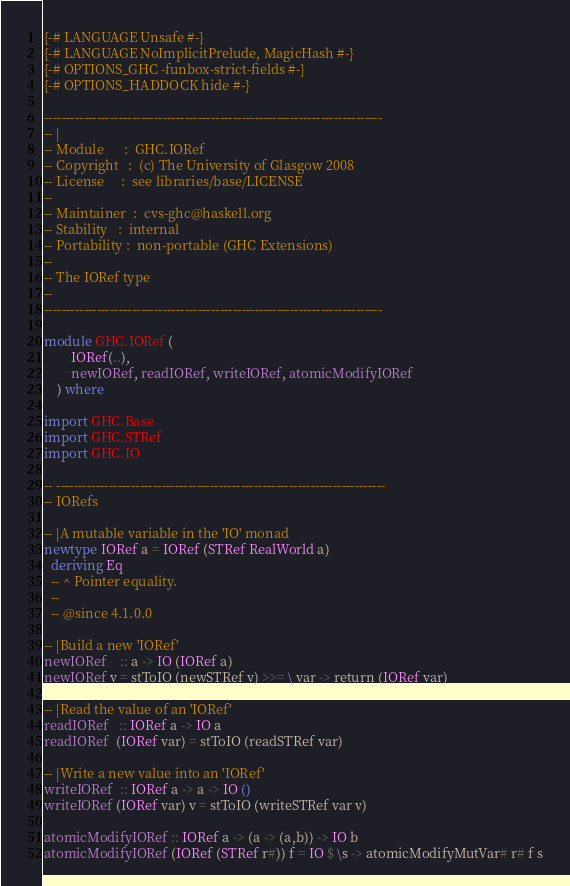Convert code to text. <code><loc_0><loc_0><loc_500><loc_500><_Haskell_>{-# LANGUAGE Unsafe #-}
{-# LANGUAGE NoImplicitPrelude, MagicHash #-}
{-# OPTIONS_GHC -funbox-strict-fields #-}
{-# OPTIONS_HADDOCK hide #-}

-----------------------------------------------------------------------------
-- |
-- Module      :  GHC.IORef
-- Copyright   :  (c) The University of Glasgow 2008
-- License     :  see libraries/base/LICENSE
--
-- Maintainer  :  cvs-ghc@haskell.org
-- Stability   :  internal
-- Portability :  non-portable (GHC Extensions)
--
-- The IORef type
--
-----------------------------------------------------------------------------

module GHC.IORef (
        IORef(..),
        newIORef, readIORef, writeIORef, atomicModifyIORef
    ) where

import GHC.Base
import GHC.STRef
import GHC.IO

-- ---------------------------------------------------------------------------
-- IORefs

-- |A mutable variable in the 'IO' monad
newtype IORef a = IORef (STRef RealWorld a)
  deriving Eq
  -- ^ Pointer equality.
  --
  -- @since 4.1.0.0

-- |Build a new 'IORef'
newIORef    :: a -> IO (IORef a)
newIORef v = stToIO (newSTRef v) >>= \ var -> return (IORef var)

-- |Read the value of an 'IORef'
readIORef   :: IORef a -> IO a
readIORef  (IORef var) = stToIO (readSTRef var)

-- |Write a new value into an 'IORef'
writeIORef  :: IORef a -> a -> IO ()
writeIORef (IORef var) v = stToIO (writeSTRef var v)

atomicModifyIORef :: IORef a -> (a -> (a,b)) -> IO b
atomicModifyIORef (IORef (STRef r#)) f = IO $ \s -> atomicModifyMutVar# r# f s

</code> 